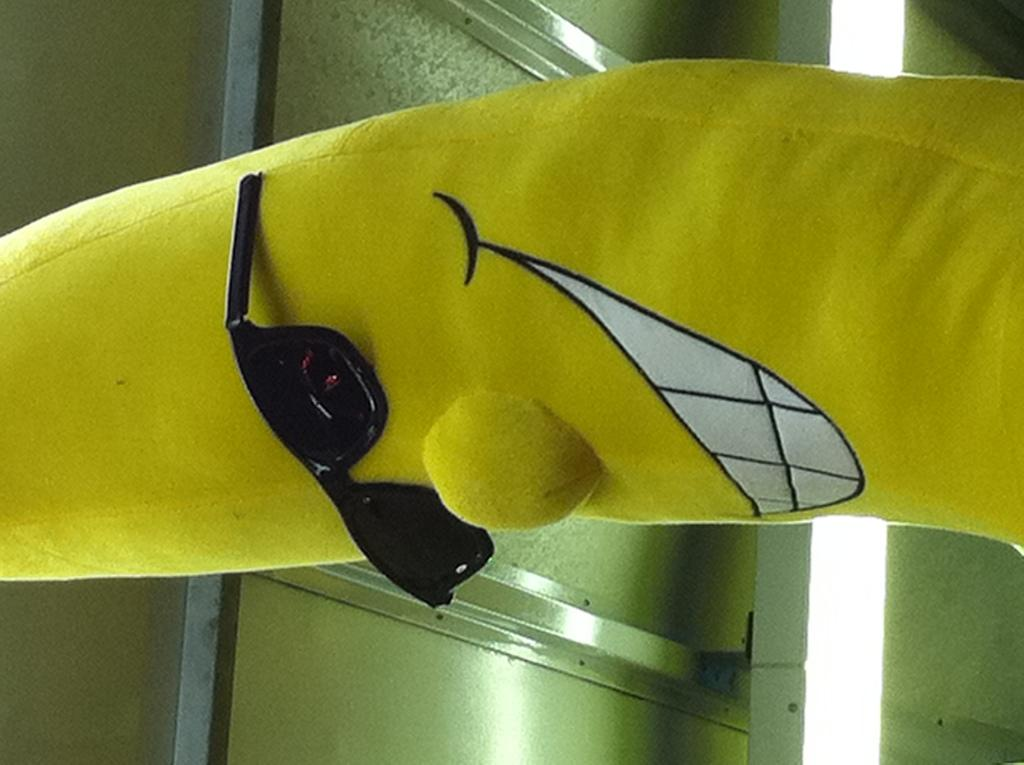What is the main subject of the image? There is a doll in the image. What accessory is the doll wearing? The doll is wearing glasses. What can be seen in the background of the image? There is light visible in the background of the image. What type of ring is the doll holding in the image? There is no ring present in the image; the doll is wearing glasses. How many pickles can be seen in the image? There are no pickles present in the image. 